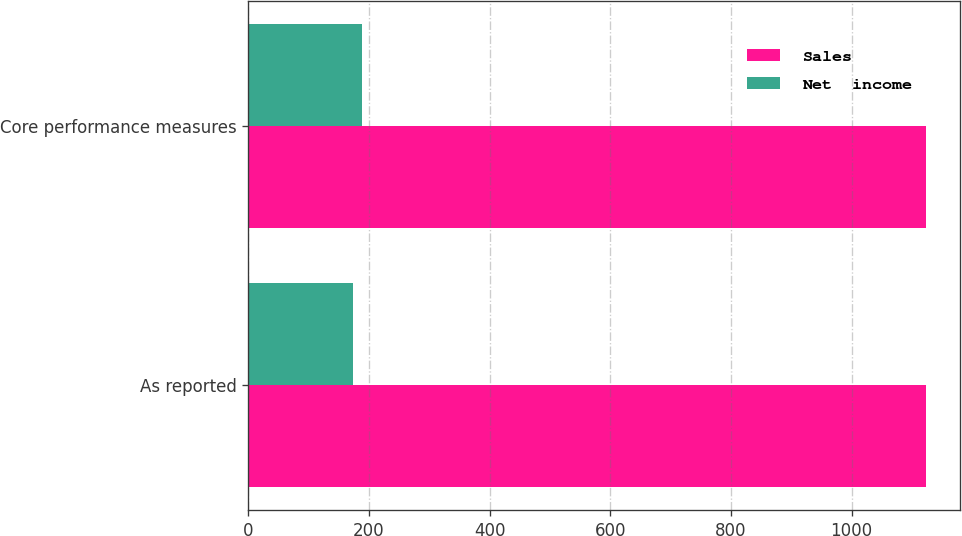Convert chart to OTSL. <chart><loc_0><loc_0><loc_500><loc_500><stacked_bar_chart><ecel><fcel>As reported<fcel>Core performance measures<nl><fcel>Sales<fcel>1124<fcel>1124<nl><fcel>Net  income<fcel>174<fcel>189<nl></chart> 